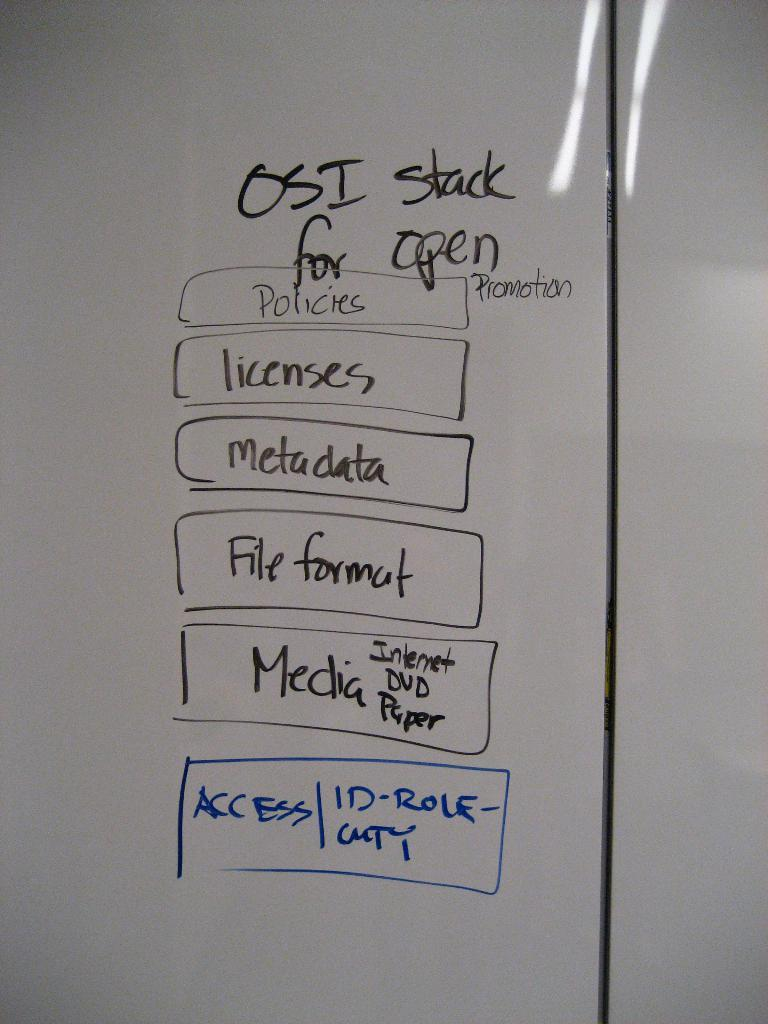Provide a one-sentence caption for the provided image. A white board with a dry erase marker list labeled OSI stack for open. 